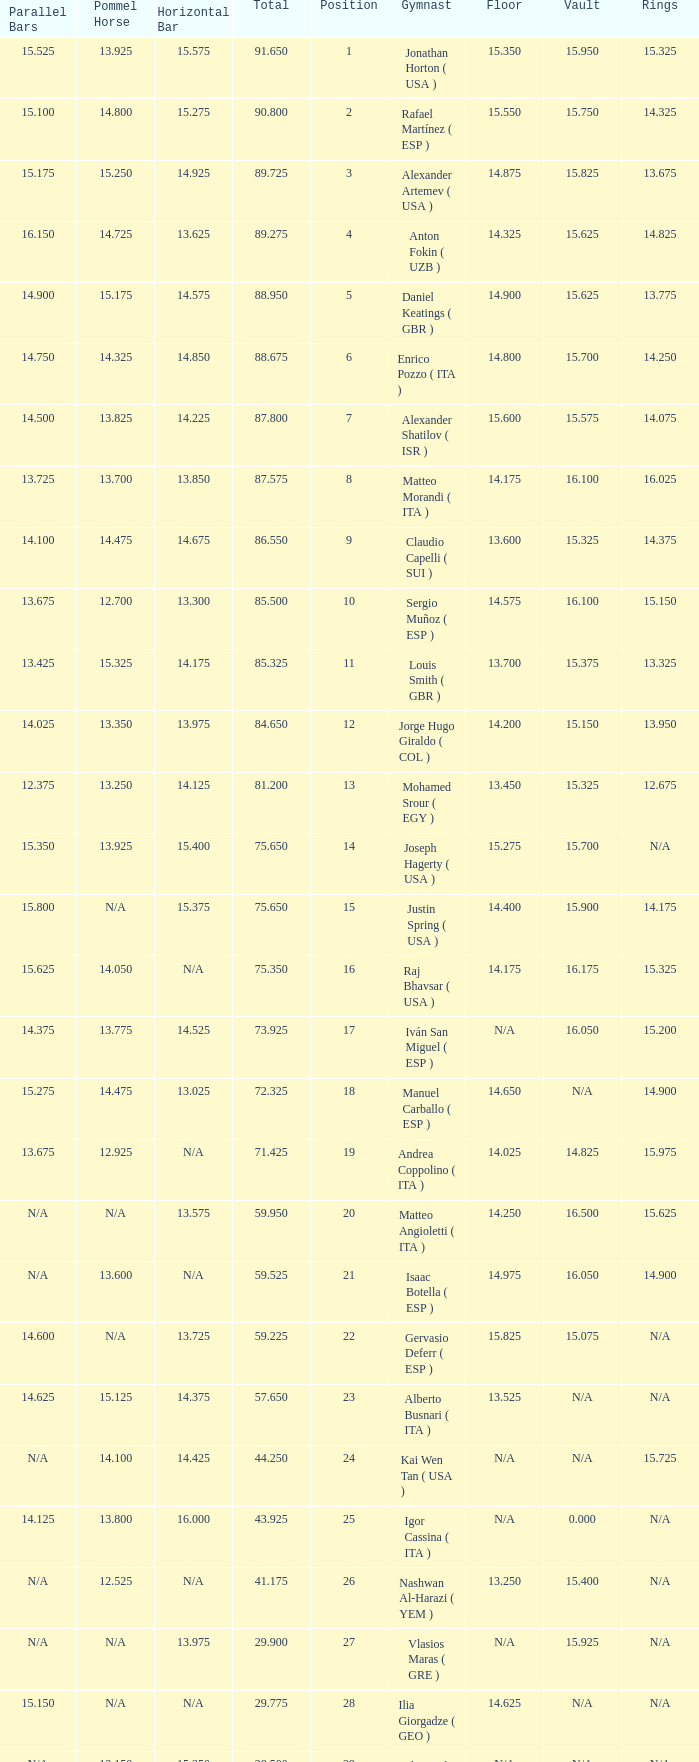If the horizontal bar is n/a and the floor is 14.175, what is the number for the parallel bars? 15.625. 